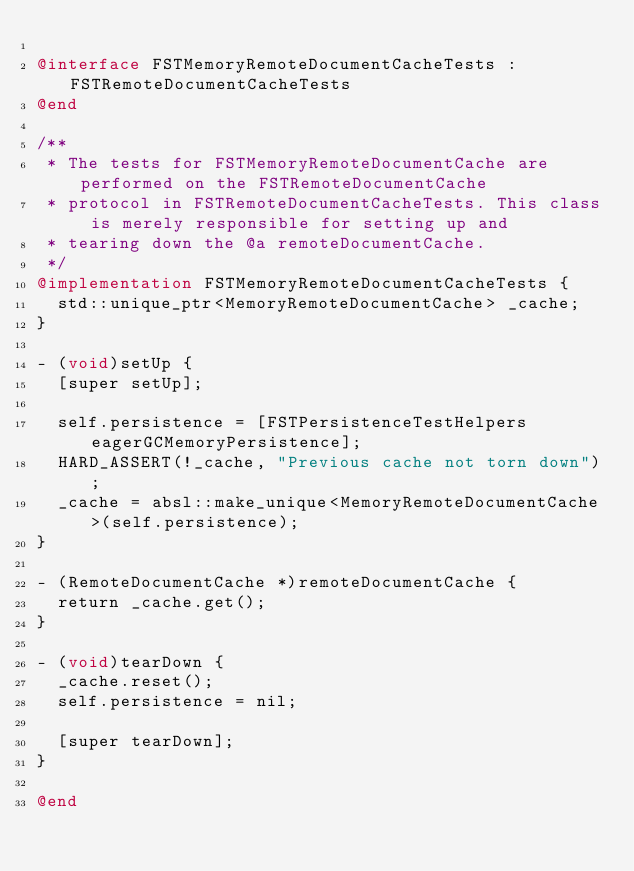Convert code to text. <code><loc_0><loc_0><loc_500><loc_500><_ObjectiveC_>
@interface FSTMemoryRemoteDocumentCacheTests : FSTRemoteDocumentCacheTests
@end

/**
 * The tests for FSTMemoryRemoteDocumentCache are performed on the FSTRemoteDocumentCache
 * protocol in FSTRemoteDocumentCacheTests. This class is merely responsible for setting up and
 * tearing down the @a remoteDocumentCache.
 */
@implementation FSTMemoryRemoteDocumentCacheTests {
  std::unique_ptr<MemoryRemoteDocumentCache> _cache;
}

- (void)setUp {
  [super setUp];

  self.persistence = [FSTPersistenceTestHelpers eagerGCMemoryPersistence];
  HARD_ASSERT(!_cache, "Previous cache not torn down");
  _cache = absl::make_unique<MemoryRemoteDocumentCache>(self.persistence);
}

- (RemoteDocumentCache *)remoteDocumentCache {
  return _cache.get();
}

- (void)tearDown {
  _cache.reset();
  self.persistence = nil;

  [super tearDown];
}

@end
</code> 